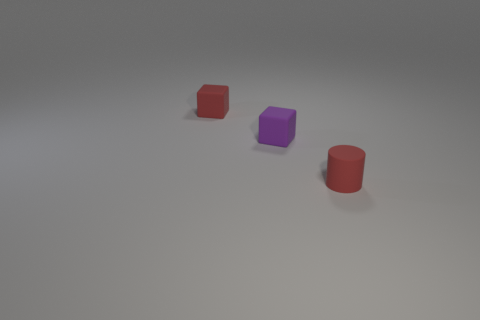Add 2 tiny cyan things. How many objects exist? 5 Subtract all cylinders. How many objects are left? 2 Subtract all cyan rubber objects. Subtract all red blocks. How many objects are left? 2 Add 1 red things. How many red things are left? 3 Add 2 brown shiny spheres. How many brown shiny spheres exist? 2 Subtract 0 gray cubes. How many objects are left? 3 